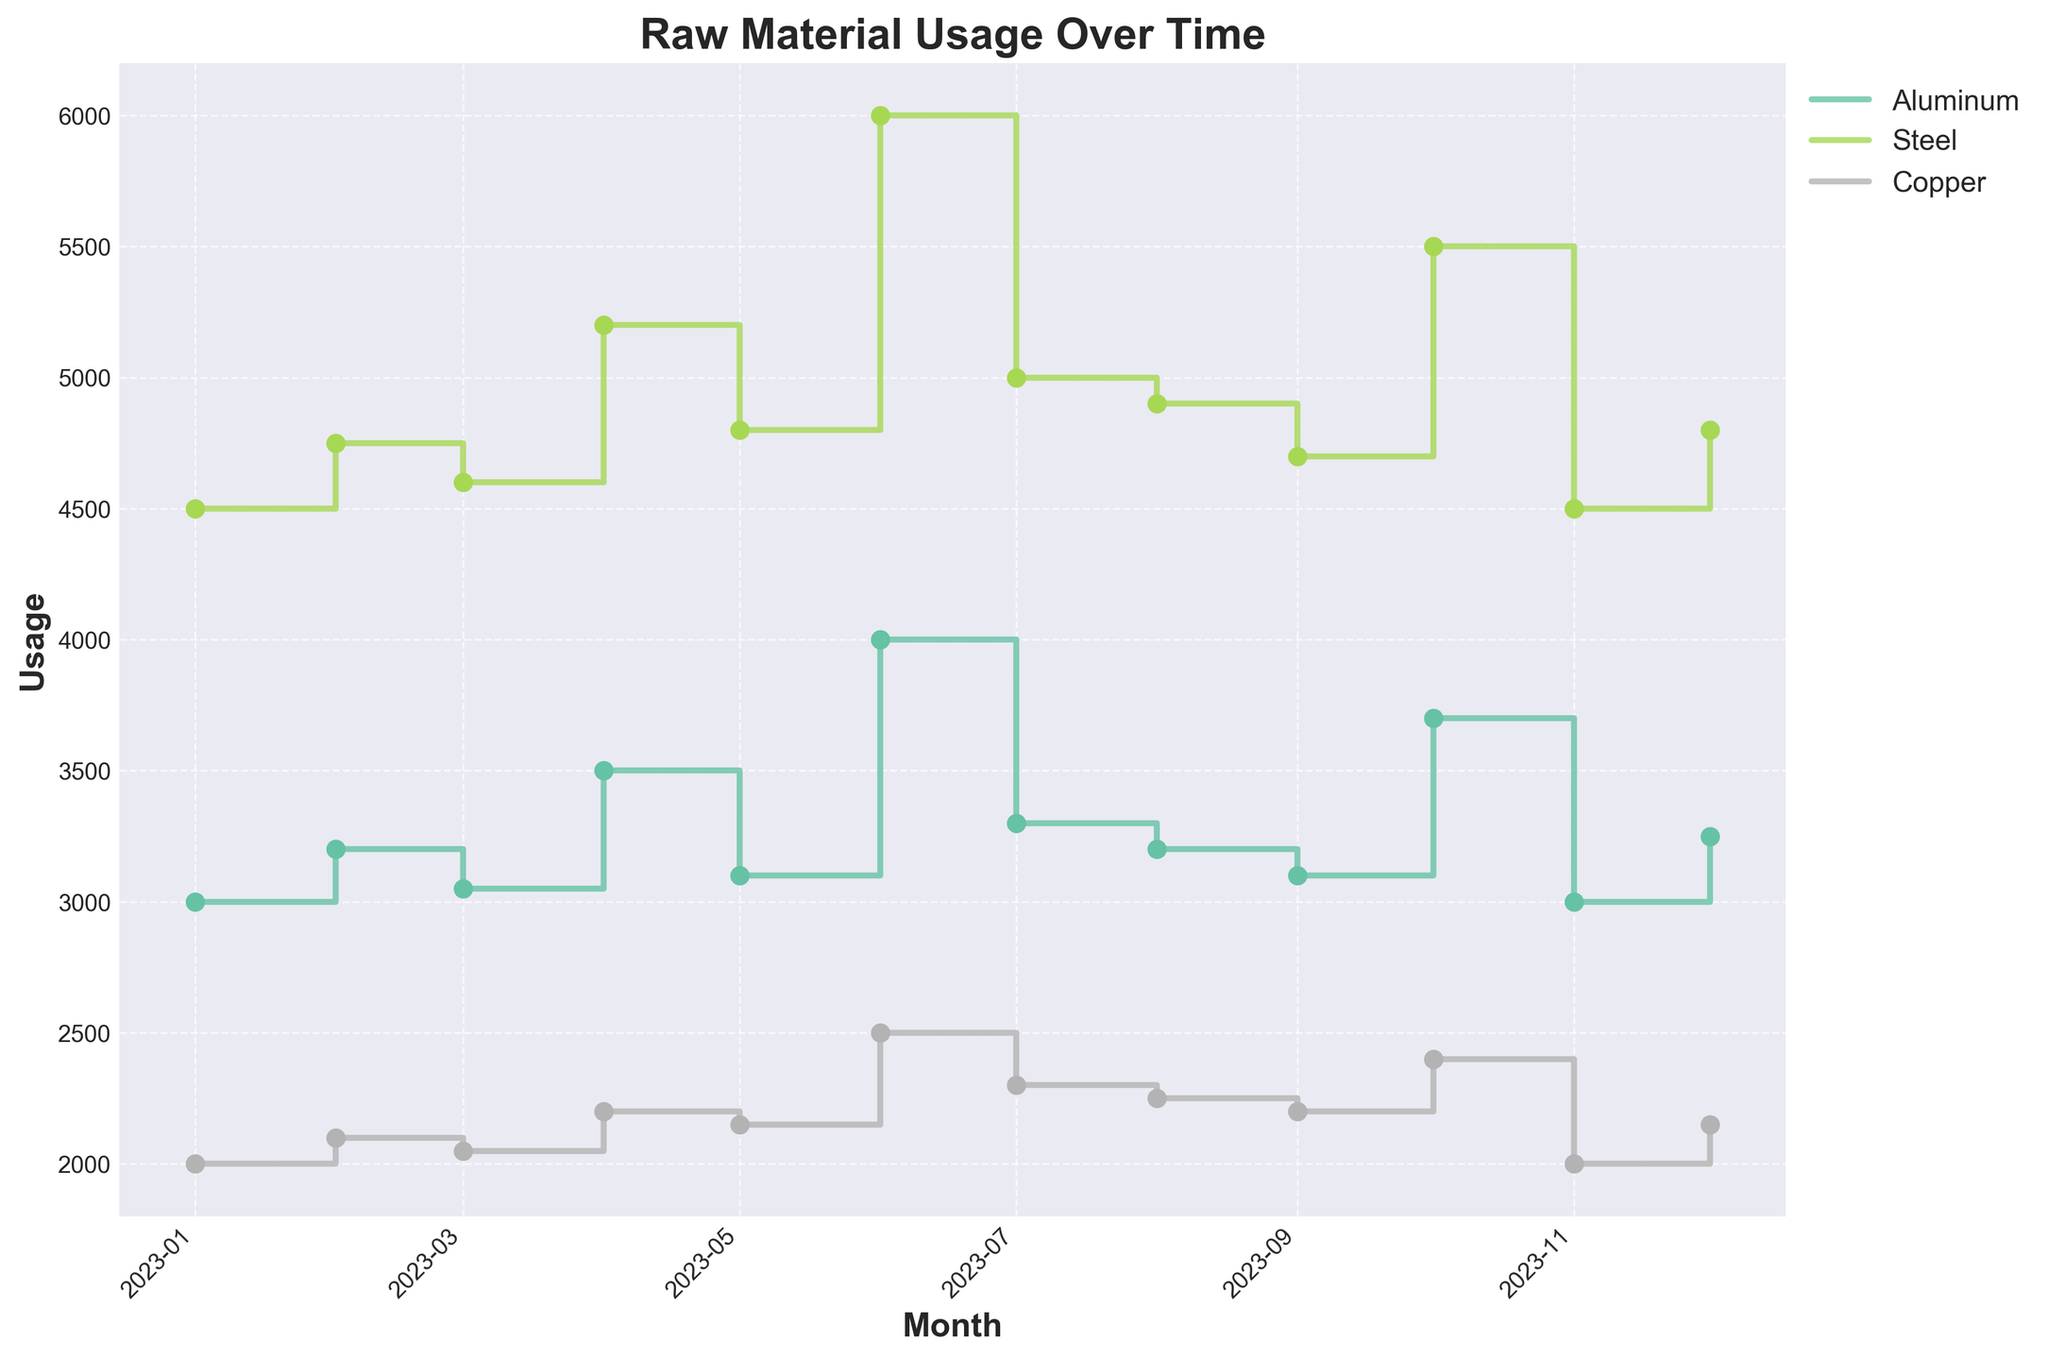What is the title of the figure? The title is usually located at the top of the figure. In this case, it reads "Raw Material Usage Over Time."
Answer: Raw Material Usage Over Time How many different materials are tracked in the figure? The figure shows three unique materials, each represented by a different colored line and marker: Aluminum, Steel, and Copper.
Answer: Three In which month did Steel usage peak? By observing the stair plot, Steel usage is highest in June, indicated by the highest point on the graph for Steel.
Answer: June What was the usage of Copper in October? Find the October data point for Copper on the graph. It's represented by a point on the Copper line.
Answer: 2400 What is the difference in Aluminum usage between January and June? Locate the data points for Aluminum in January and June, then subtract January's value from June's value: 4000 - 3000.
Answer: 1000 Which material showed the largest increase in usage from August to September? Comparing the step increases for each material between August and September, none show an increase but examining their trends instead: Copper shows the smallest decrease, while the other stay stable or decrease.
Answer: None show an increase What is the average monthly Steel usage from January to December? To find the average, sum the Steel usage for each month and divide by the number of months, i.e., (4500 + 4750 + 4600 + 5200 + 4800 + 6000 + 5000 + 4900 + 4700 + 5500 + 4500 + 4800) / 12.
Answer: 4954.17 How does Aluminum usage in December compare to November? Analyze the plot points for Aluminum in November and December; December's usage is higher.
Answer: Increased What can be inferred about the periods of over-consumption for Steel? Steel shows abnormal spikes in April, June, and October as indicated by the sharp increases in the stair plot.
Answer: April, June, October When did all three materials show an increased usage on the same month? Examine points in the plot where all three materials have rising steps: in April.
Answer: April 